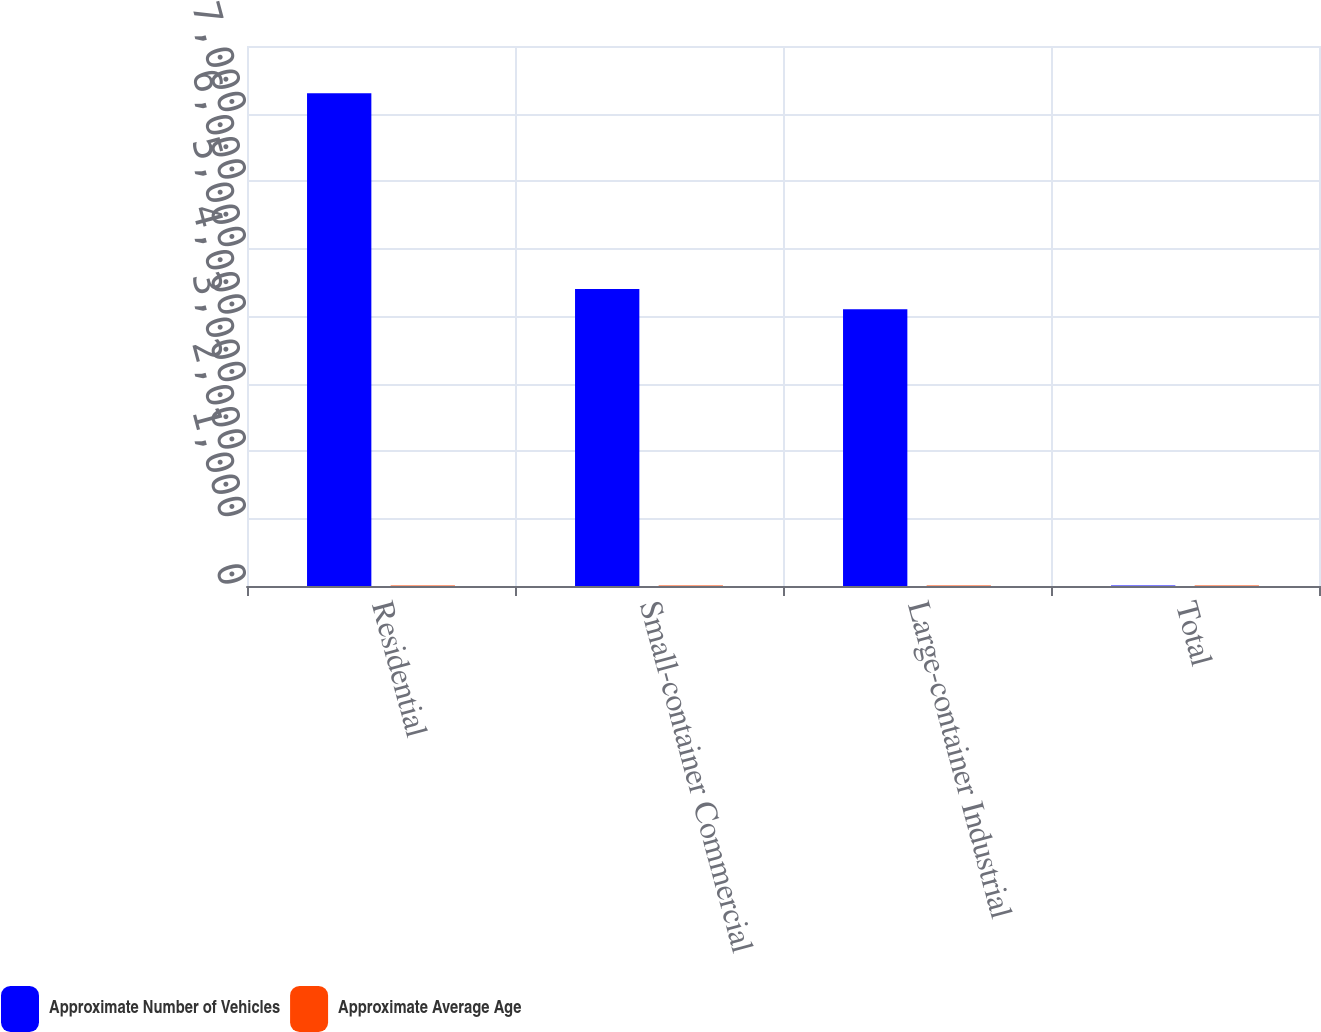Convert chart. <chart><loc_0><loc_0><loc_500><loc_500><stacked_bar_chart><ecel><fcel>Residential<fcel>Small-container Commercial<fcel>Large-container Industrial<fcel>Total<nl><fcel>Approximate Number of Vehicles<fcel>7300<fcel>4400<fcel>4100<fcel>9<nl><fcel>Approximate Average Age<fcel>7<fcel>7<fcel>9<fcel>7.5<nl></chart> 